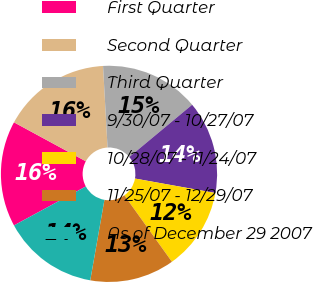Convert chart to OTSL. <chart><loc_0><loc_0><loc_500><loc_500><pie_chart><fcel>First Quarter<fcel>Second Quarter<fcel>Third Quarter<fcel>9/30/07 - 10/27/07<fcel>10/28/07 - 11/24/07<fcel>11/25/07 - 12/29/07<fcel>As of December 29 2007<nl><fcel>15.82%<fcel>16.21%<fcel>14.84%<fcel>13.87%<fcel>12.28%<fcel>12.66%<fcel>14.31%<nl></chart> 